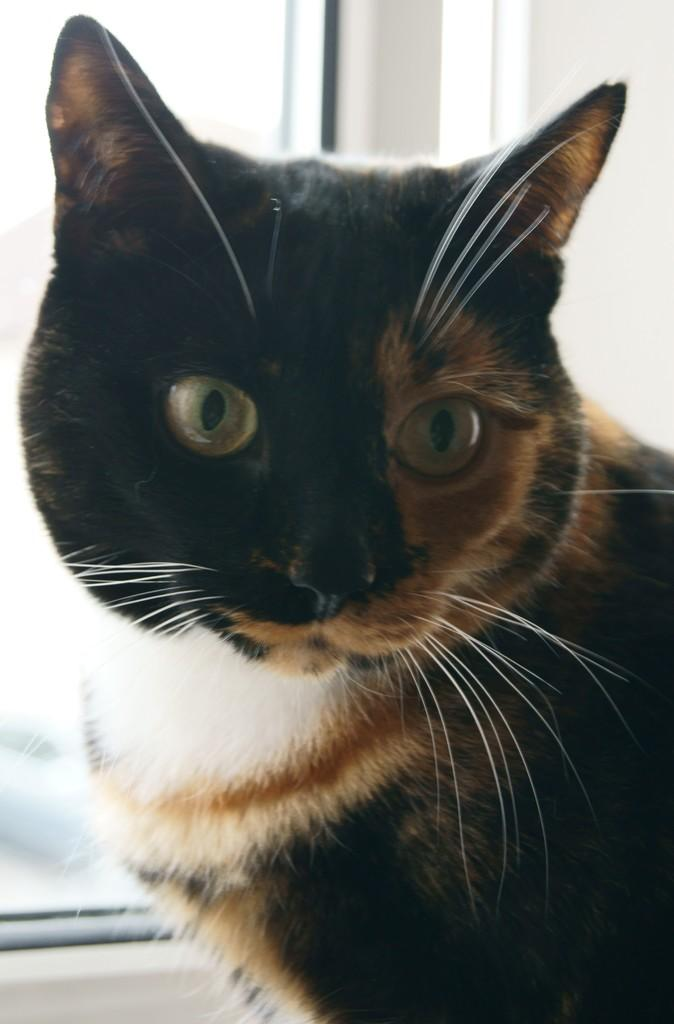What is the main subject of the image? There is a cat in the center of the image. What can be seen in the background of the image? There is a wall and a window in the background of the image. What color is the rose on the cat's collar in the image? There is no rose or collar present on the cat in the image. 